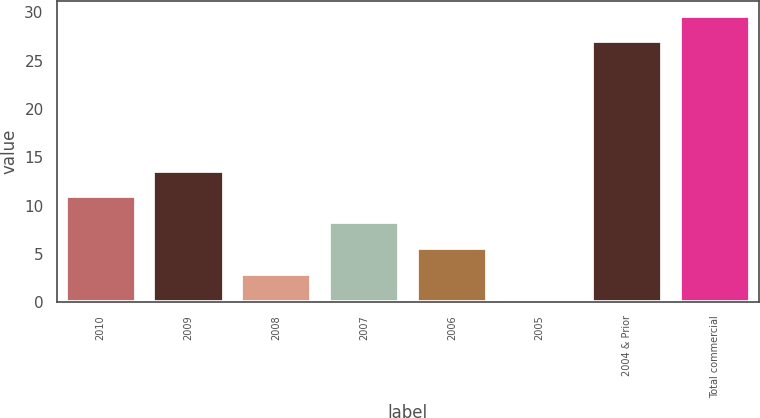Convert chart to OTSL. <chart><loc_0><loc_0><loc_500><loc_500><bar_chart><fcel>2010<fcel>2009<fcel>2008<fcel>2007<fcel>2006<fcel>2005<fcel>2004 & Prior<fcel>Total commercial<nl><fcel>10.95<fcel>13.62<fcel>2.94<fcel>8.28<fcel>5.61<fcel>0.27<fcel>27<fcel>29.67<nl></chart> 